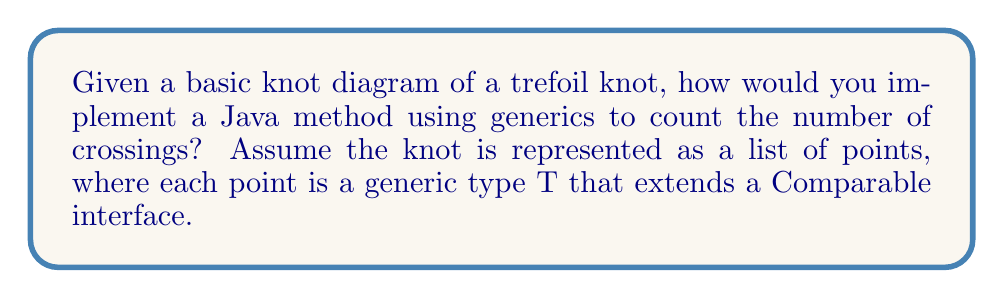Could you help me with this problem? To solve this problem, we'll follow these steps:

1. Understand the representation:
   The trefoil knot is represented as a list of points of type T, where T extends Comparable.

2. Create a generic method signature:
   ```java
   public static <T extends Comparable<T>> int countCrossings(List<T> knotPoints)
   ```

3. Implement the crossing counting algorithm:
   a. Iterate through each pair of line segments in the knot diagram.
   b. For each pair, check if they intersect.
   c. Count the number of intersections.

4. The trefoil knot has 3 crossings, so our method should return 3.

5. Pseudocode for the method:
   ```
   function countCrossings(knotPoints):
     crossings = 0
     for i = 0 to knotPoints.size() - 1:
       for j = i + 2 to knotPoints.size() - 1:
         if (segmentsIntersect(knotPoints[i], knotPoints[i+1], knotPoints[j], knotPoints[(j+1) % knotPoints.size()])):
           crossings++
     return crossings
   ```

6. Note: The actual implementation of `segmentsIntersect` would depend on how the generic type T is defined and how comparisons are made.

For a trefoil knot, this method would iterate through all pairs of line segments and identify the 3 crossings, returning the correct count.
Answer: 3 